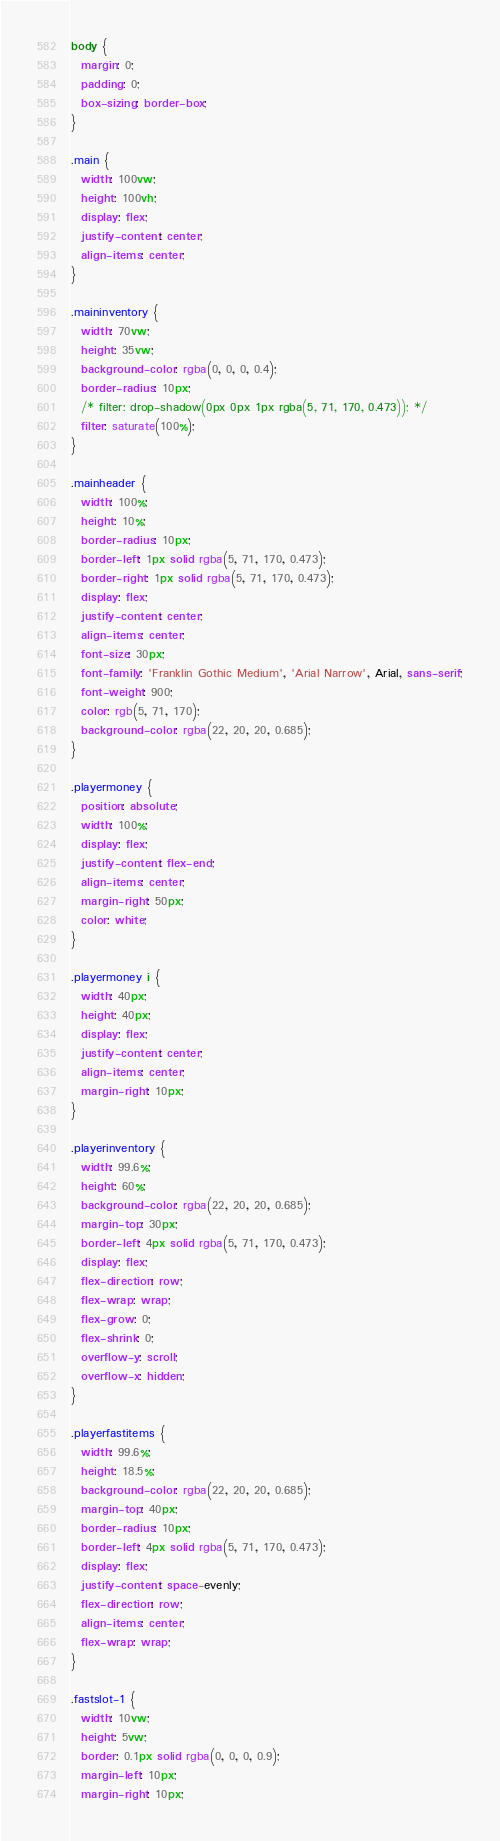Convert code to text. <code><loc_0><loc_0><loc_500><loc_500><_CSS_>body {
  margin: 0;
  padding: 0;
  box-sizing: border-box;
}

.main {
  width: 100vw;
  height: 100vh;
  display: flex;
  justify-content: center;
  align-items: center;
}

.maininventory {
  width: 70vw;
  height: 35vw;
  background-color: rgba(0, 0, 0, 0.4);
  border-radius: 10px;
  /* filter: drop-shadow(0px 0px 1px rgba(5, 71, 170, 0.473)); */
  filter: saturate(100%);
}

.mainheader {
  width: 100%;
  height: 10%;
  border-radius: 10px;
  border-left: 1px solid rgba(5, 71, 170, 0.473);
  border-right: 1px solid rgba(5, 71, 170, 0.473);
  display: flex;
  justify-content: center;
  align-items: center;
  font-size: 30px;
  font-family: 'Franklin Gothic Medium', 'Arial Narrow', Arial, sans-serif;
  font-weight: 900;
  color: rgb(5, 71, 170);
  background-color: rgba(22, 20, 20, 0.685);
}

.playermoney {
  position: absolute;
  width: 100%;
  display: flex;
  justify-content: flex-end;
  align-items: center;
  margin-right: 50px;
  color: white;
}

.playermoney i {
  width: 40px;
  height: 40px;
  display: flex;
  justify-content: center;
  align-items: center;
  margin-right: 10px;
}

.playerinventory {
  width: 99.6%;
  height: 60%;
  background-color: rgba(22, 20, 20, 0.685);
  margin-top: 30px;
  border-left: 4px solid rgba(5, 71, 170, 0.473);
  display: flex;
  flex-direction: row;
  flex-wrap: wrap;
  flex-grow: 0;
  flex-shrink: 0;
  overflow-y: scroll;
  overflow-x: hidden;
}

.playerfastitems {
  width: 99.6%;
  height: 18.5%;
  background-color: rgba(22, 20, 20, 0.685);
  margin-top: 40px;
  border-radius: 10px;
  border-left: 4px solid rgba(5, 71, 170, 0.473);
  display: flex;
  justify-content: space-evenly;
  flex-direction: row;
  align-items: center;
  flex-wrap: wrap;
}

.fastslot-1 {
  width: 10vw;
  height: 5vw;
  border: 0.1px solid rgba(0, 0, 0, 0.9);
  margin-left: 10px;
  margin-right: 10px;</code> 